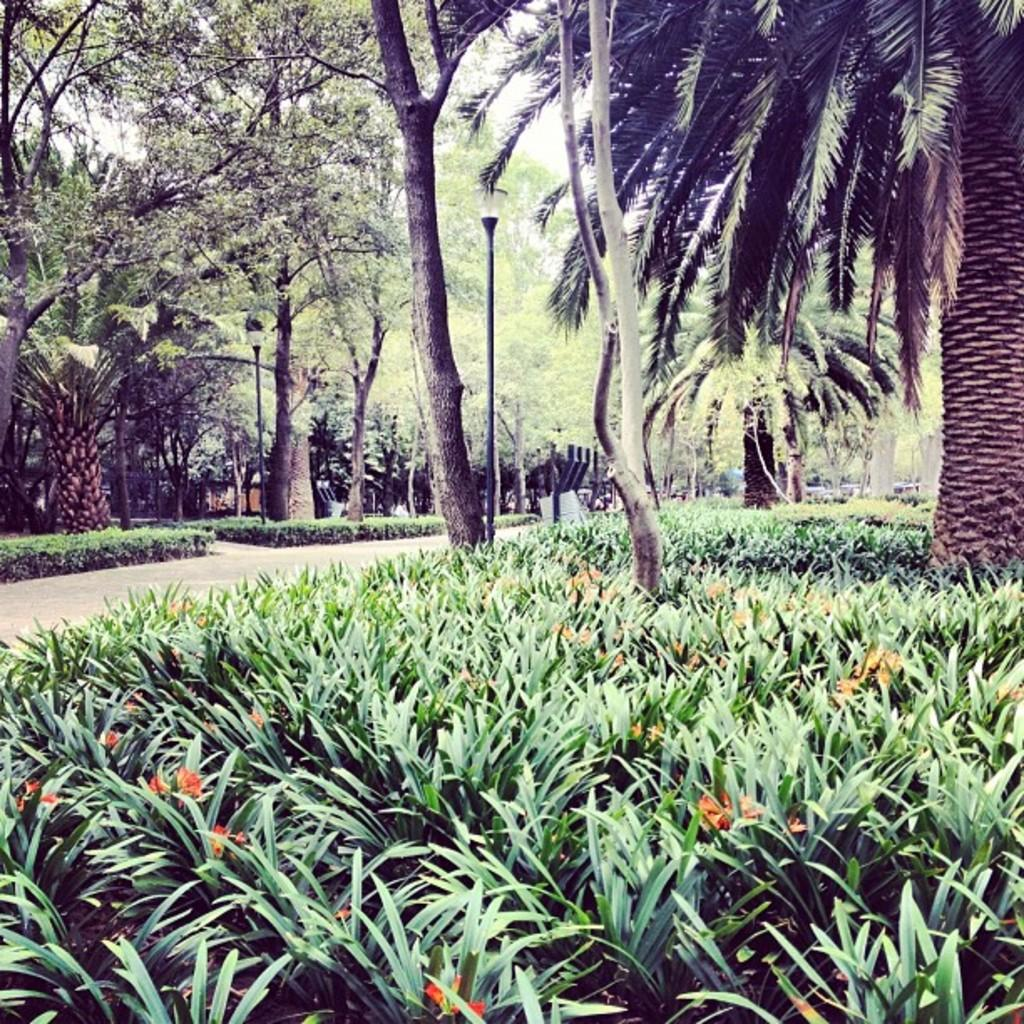What type of location is depicted in the image? The image appears to depict a park. What type of vegetation can be seen in the image? There are flower plants and trees in the image. What type of request is being made in the image? There is no request present in the image; it depicts a park with flower plants and trees. 